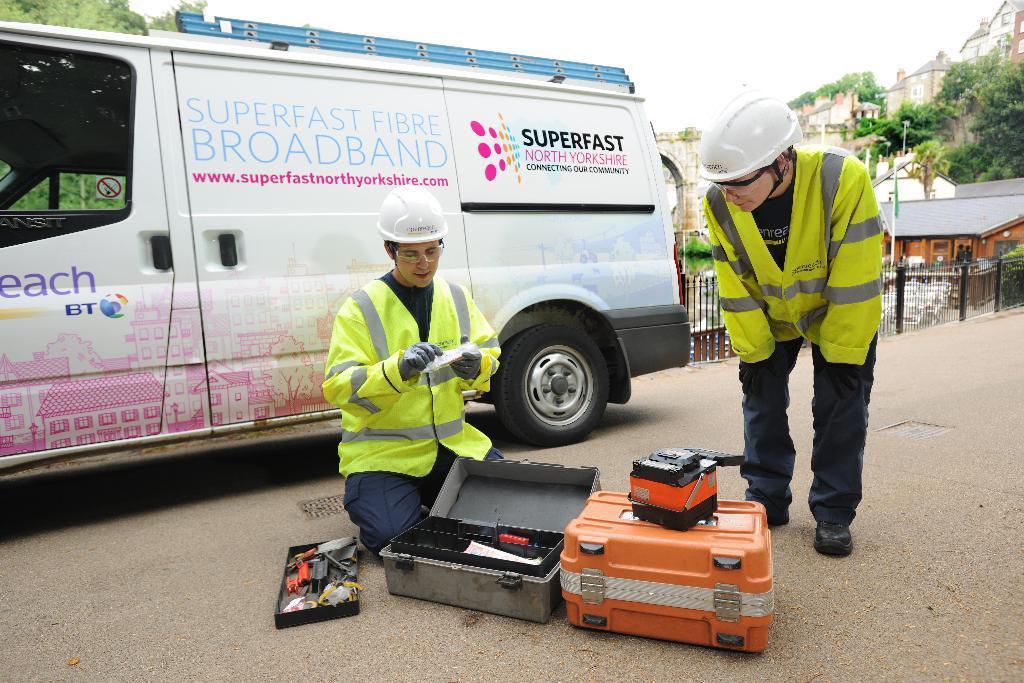Please provide a concise description of this image. In this image I can see 2 people wearing white helmet, coat and gloves. There are 2 briefcases. There is a vehicle, fence, buildings and trees at the back. 